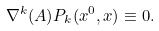Convert formula to latex. <formula><loc_0><loc_0><loc_500><loc_500>\nabla ^ { k } ( A ) P _ { k } ( x ^ { 0 } , { x } ) \equiv 0 .</formula> 